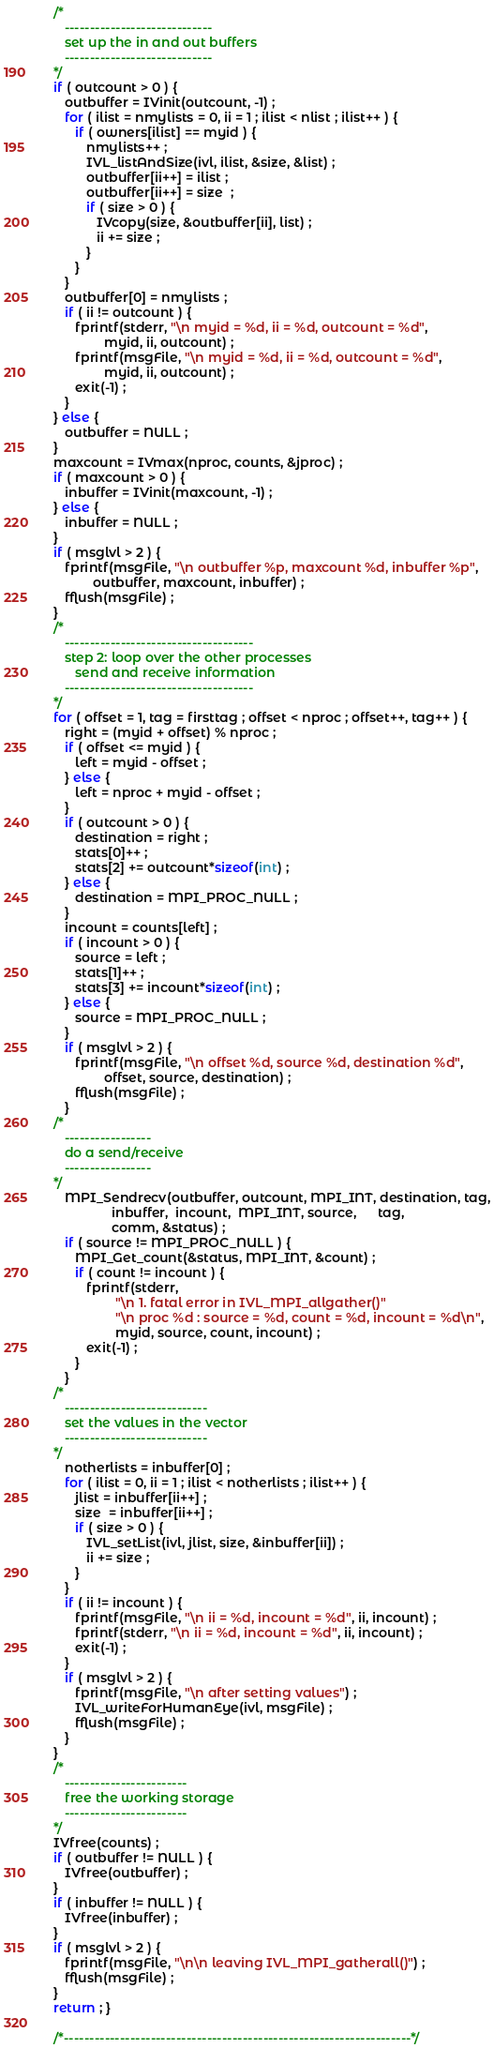Convert code to text. <code><loc_0><loc_0><loc_500><loc_500><_C_>/*
   -----------------------------
   set up the in and out buffers
   -----------------------------
*/
if ( outcount > 0 ) {
   outbuffer = IVinit(outcount, -1) ;
   for ( ilist = nmylists = 0, ii = 1 ; ilist < nlist ; ilist++ ) {
      if ( owners[ilist] == myid ) {
         nmylists++ ;
         IVL_listAndSize(ivl, ilist, &size, &list) ;
         outbuffer[ii++] = ilist ;
         outbuffer[ii++] = size  ;
         if ( size > 0 ) {
            IVcopy(size, &outbuffer[ii], list) ;
            ii += size ;
         }
      }
   }
   outbuffer[0] = nmylists ;
   if ( ii != outcount ) {
      fprintf(stderr, "\n myid = %d, ii = %d, outcount = %d",
              myid, ii, outcount) ;
      fprintf(msgFile, "\n myid = %d, ii = %d, outcount = %d",
              myid, ii, outcount) ;
      exit(-1) ;
   }
} else {
   outbuffer = NULL ;
}
maxcount = IVmax(nproc, counts, &jproc) ;
if ( maxcount > 0 ) {
   inbuffer = IVinit(maxcount, -1) ;
} else {
   inbuffer = NULL ;
}
if ( msglvl > 2 ) {
   fprintf(msgFile, "\n outbuffer %p, maxcount %d, inbuffer %p",
           outbuffer, maxcount, inbuffer) ;
   fflush(msgFile) ;
}
/*
   -------------------------------------
   step 2: loop over the other processes
      send and receive information
   -------------------------------------
*/
for ( offset = 1, tag = firsttag ; offset < nproc ; offset++, tag++ ) {
   right = (myid + offset) % nproc ;
   if ( offset <= myid ) {
      left = myid - offset ;
   } else {
      left = nproc + myid - offset ;
   }
   if ( outcount > 0 ) {
      destination = right ;
      stats[0]++ ;
      stats[2] += outcount*sizeof(int) ;
   } else {
      destination = MPI_PROC_NULL ;
   }
   incount = counts[left] ;
   if ( incount > 0 ) {
      source = left ;
      stats[1]++ ;
      stats[3] += incount*sizeof(int) ;
   } else {
      source = MPI_PROC_NULL ;
   }
   if ( msglvl > 2 ) {
      fprintf(msgFile, "\n offset %d, source %d, destination %d",
              offset, source, destination) ;
      fflush(msgFile) ;
   }
/*
   -----------------
   do a send/receive
   -----------------
*/
   MPI_Sendrecv(outbuffer, outcount, MPI_INT, destination, tag,
                inbuffer,  incount,  MPI_INT, source,      tag,
                comm, &status) ;
   if ( source != MPI_PROC_NULL ) {
      MPI_Get_count(&status, MPI_INT, &count) ;
      if ( count != incount ) {
         fprintf(stderr,
                 "\n 1. fatal error in IVL_MPI_allgather()"
                 "\n proc %d : source = %d, count = %d, incount = %d\n",
                 myid, source, count, incount) ;
         exit(-1) ;
      }
   }
/*
   ----------------------------
   set the values in the vector
   ----------------------------
*/
   notherlists = inbuffer[0] ;
   for ( ilist = 0, ii = 1 ; ilist < notherlists ; ilist++ ) {
      jlist = inbuffer[ii++] ;
      size  = inbuffer[ii++] ;
      if ( size > 0 ) {
         IVL_setList(ivl, jlist, size, &inbuffer[ii]) ;
         ii += size ;
      }
   }
   if ( ii != incount ) {
      fprintf(msgFile, "\n ii = %d, incount = %d", ii, incount) ;
      fprintf(stderr, "\n ii = %d, incount = %d", ii, incount) ;
      exit(-1) ;
   }
   if ( msglvl > 2 ) {
      fprintf(msgFile, "\n after setting values") ;
      IVL_writeForHumanEye(ivl, msgFile) ;
      fflush(msgFile) ;
   }
}
/*
   ------------------------
   free the working storage
   ------------------------
*/
IVfree(counts) ;
if ( outbuffer != NULL ) {
   IVfree(outbuffer) ;
}
if ( inbuffer != NULL ) {
   IVfree(inbuffer) ;
}
if ( msglvl > 2 ) {
   fprintf(msgFile, "\n\n leaving IVL_MPI_gatherall()") ;
   fflush(msgFile) ;
}
return ; }

/*--------------------------------------------------------------------*/
</code> 